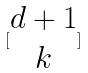Convert formula to latex. <formula><loc_0><loc_0><loc_500><loc_500>[ \begin{matrix} d + 1 \\ k \end{matrix} ]</formula> 